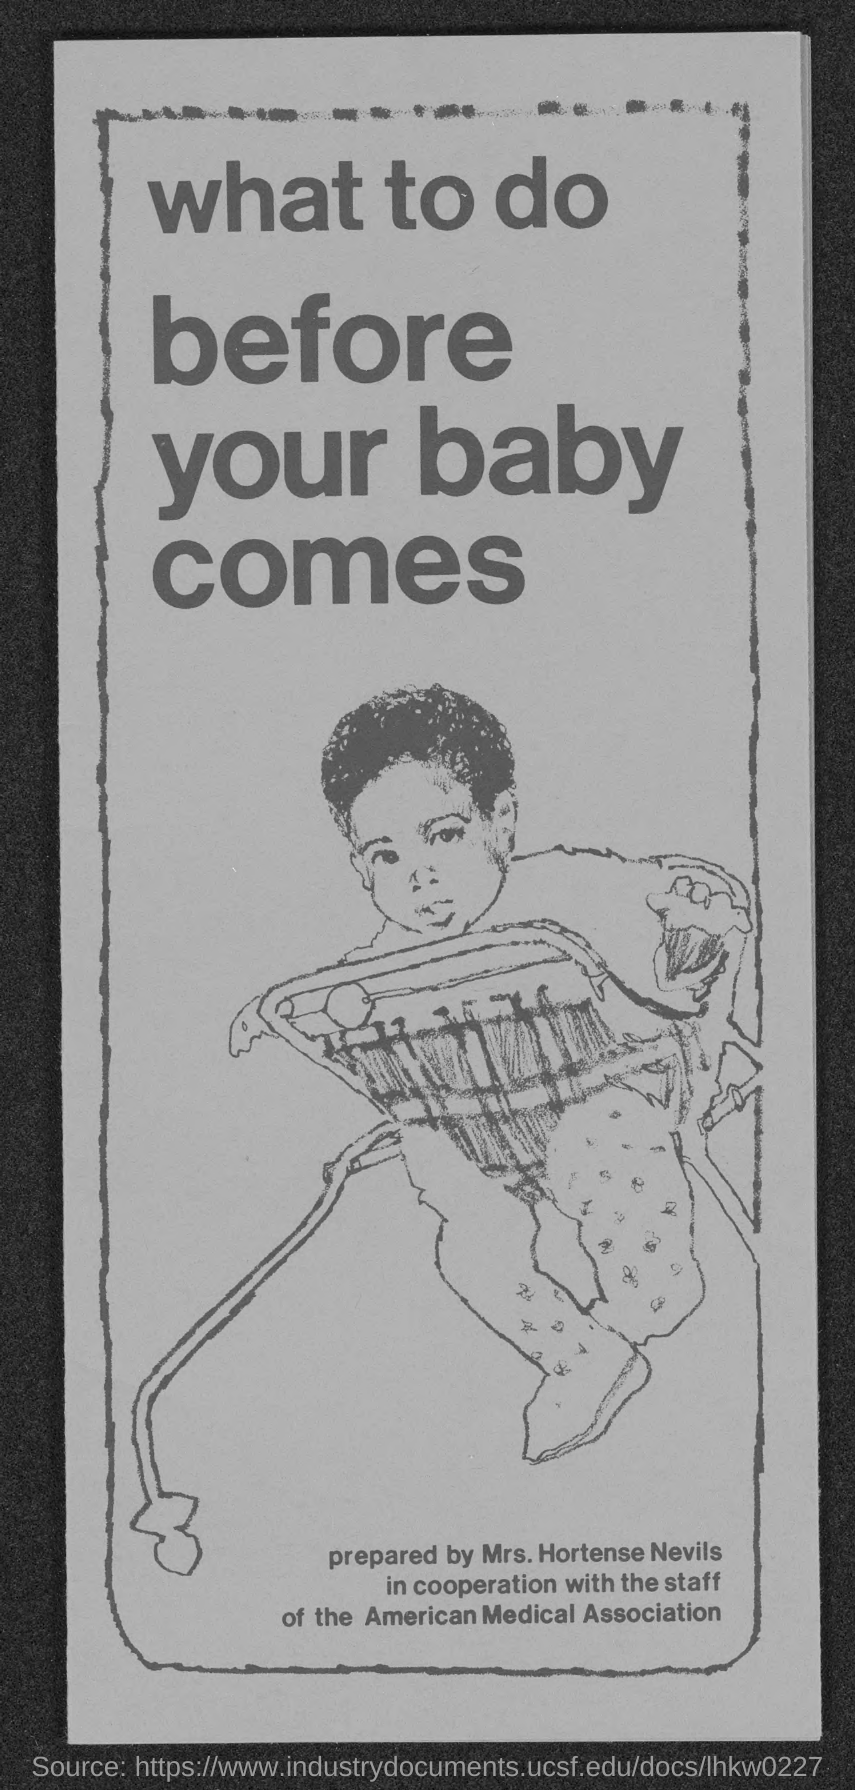Who prepare the document?
Keep it short and to the point. Mrs. Hortense Nevils. 